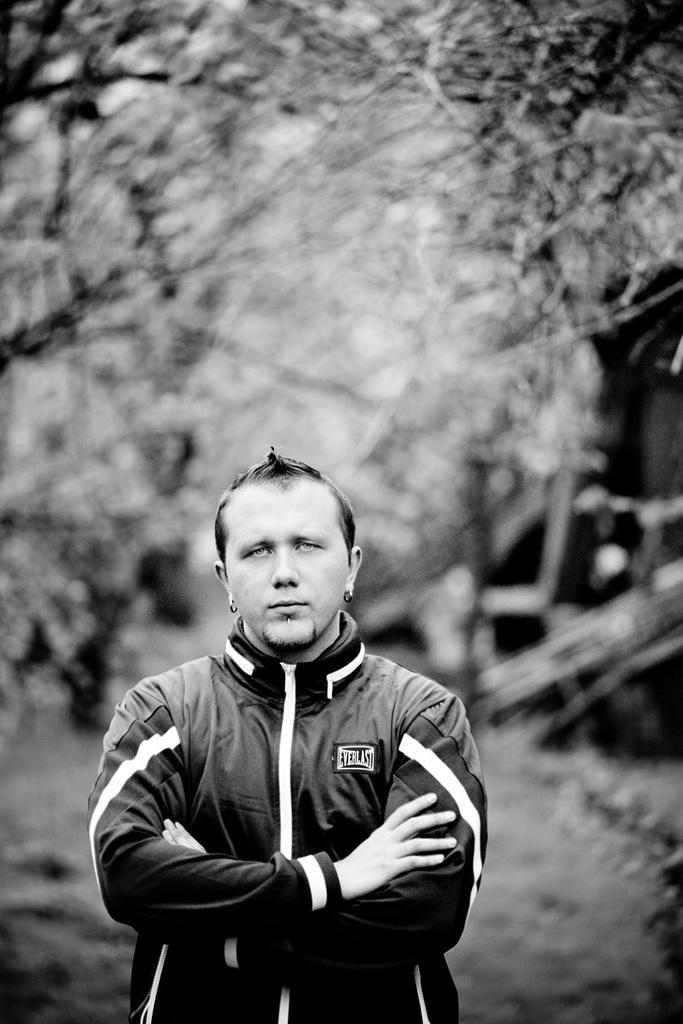Can you describe this image briefly? It is a black and white image, there is a person standing in the front and the background of the person is blur. 